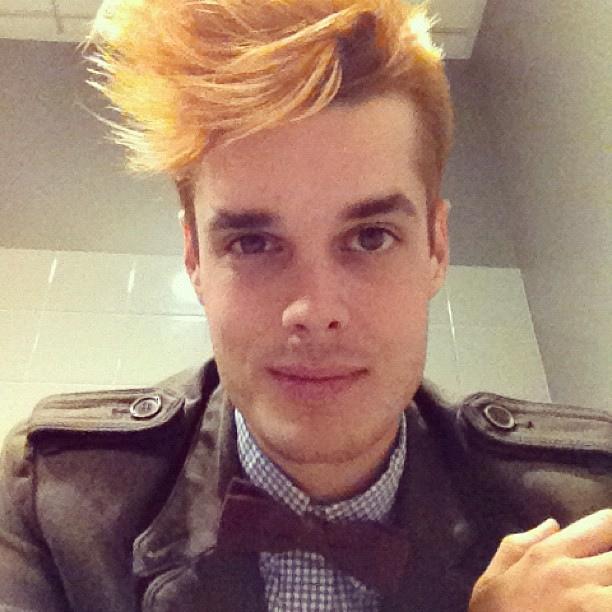What color is the man's hair?
Be succinct. Blonde. Does this man need to shave?
Be succinct. No. Is this man wearing a bow tie?
Keep it brief. Yes. 